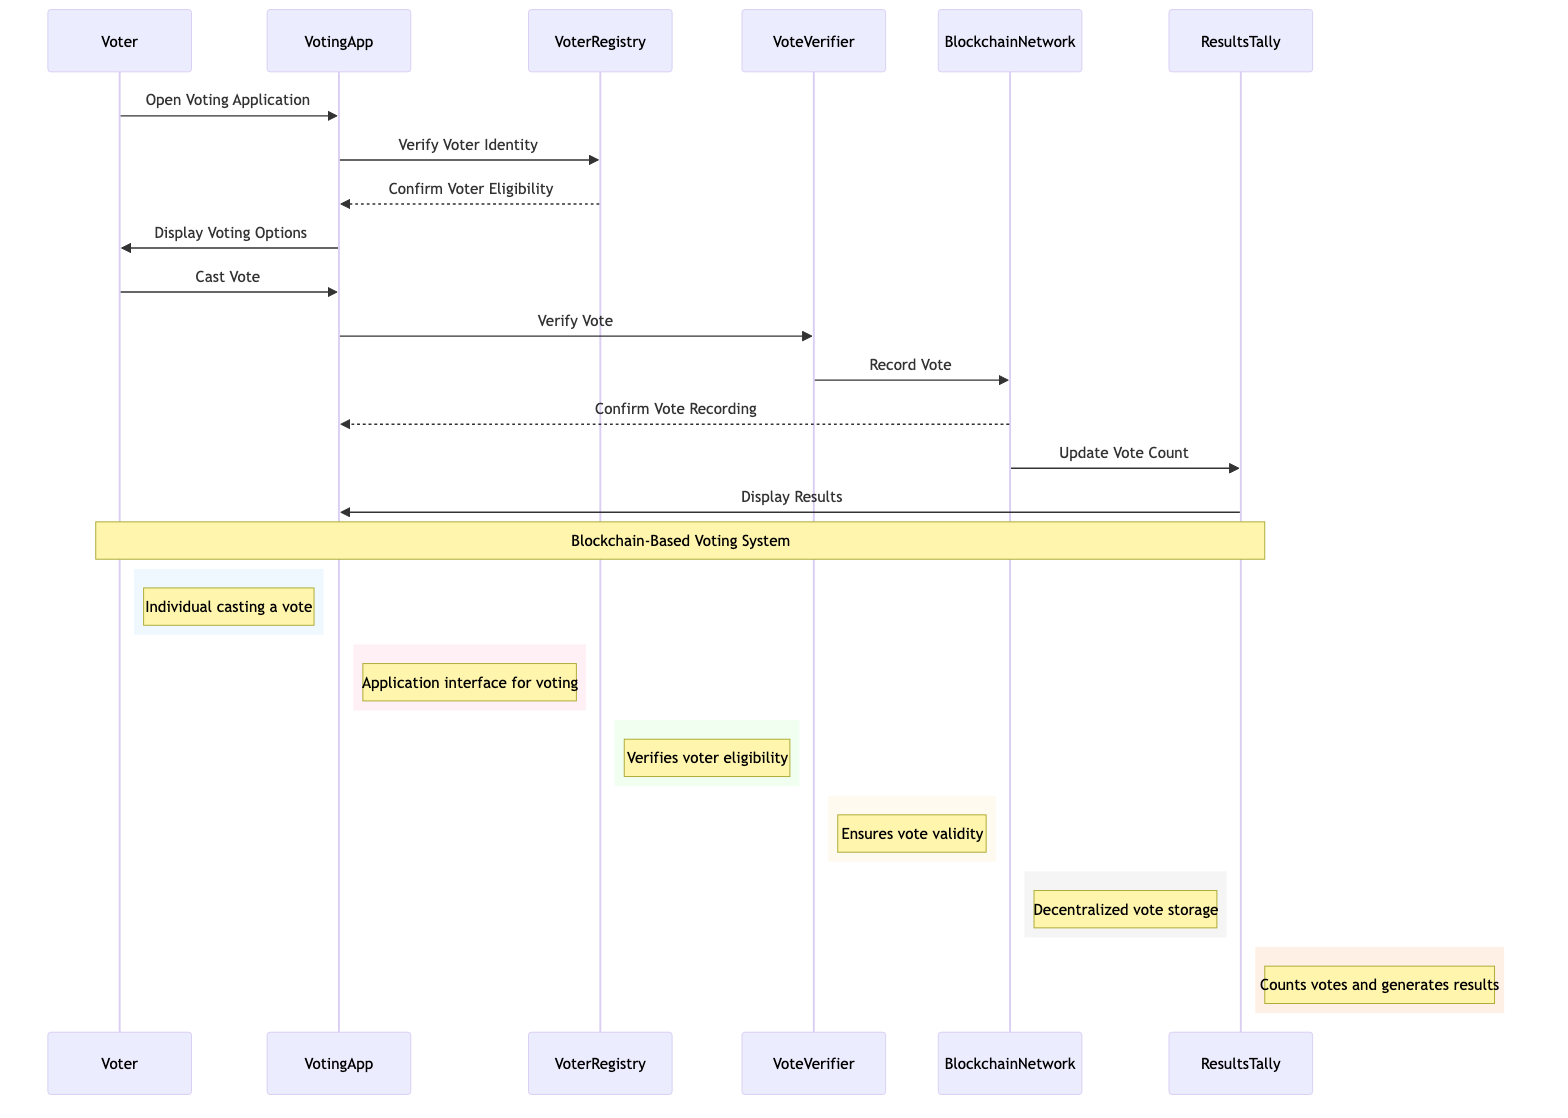What is the first action taken by the Voter? The first action taken by the Voter in the sequence is to open the Voting Application, as indicated by the message flowing from the Voter to the VotingApp.
Answer: Open Voting Application How many actors are involved in the voting process? In the sequence diagram, there are six actors involved: Voter, VotingApp, VoterRegistry, VoteVerifier, BlockchainNetwork, and ResultsTally.
Answer: Six What does the VotingApp do after confirming voter eligibility? After confirming voter eligibility, the VotingApp displays the voting options to the voter, as shown by the message sent from VotingApp to Voter.
Answer: Display Voting Options Which actor is responsible for ensuring the validity of the vote? The VoteVerifier is responsible for ensuring the validity of the vote, as indicated by its role in the sequence of messages where it verifies the vote before it is recorded in the BlockchainNetwork.
Answer: VoteVerifier What action follows the confirmation of vote recording by the BlockchainNetwork? After the BlockchainNetwork confirms the vote recording, it updates the vote count to the ResultsTally, which is the next step in the sequence after the confirmation.
Answer: Update Vote Count What is the final action taken in this sequence? The final action taken in this sequence is when the ResultsTally displays the results to the VotingApp, which concludes the voting process.
Answer: Display Results What element governs vote verification, eligibility, and tallying? The SmartContract governs vote verification, eligibility, and tallying, as it is a predefined contract on the blockchain that sets the rules for these processes.
Answer: SmartContract 